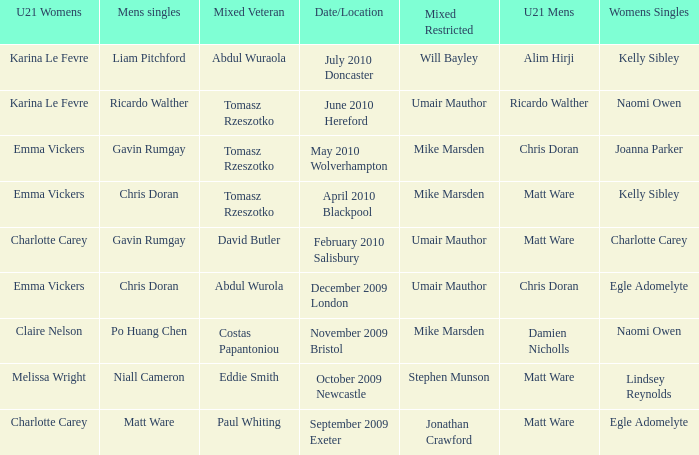When and where did Eddie Smith win the mixed veteran? 1.0. Would you be able to parse every entry in this table? {'header': ['U21 Womens', 'Mens singles', 'Mixed Veteran', 'Date/Location', 'Mixed Restricted', 'U21 Mens', 'Womens Singles'], 'rows': [['Karina Le Fevre', 'Liam Pitchford', 'Abdul Wuraola', 'July 2010 Doncaster', 'Will Bayley', 'Alim Hirji', 'Kelly Sibley'], ['Karina Le Fevre', 'Ricardo Walther', 'Tomasz Rzeszotko', 'June 2010 Hereford', 'Umair Mauthor', 'Ricardo Walther', 'Naomi Owen'], ['Emma Vickers', 'Gavin Rumgay', 'Tomasz Rzeszotko', 'May 2010 Wolverhampton', 'Mike Marsden', 'Chris Doran', 'Joanna Parker'], ['Emma Vickers', 'Chris Doran', 'Tomasz Rzeszotko', 'April 2010 Blackpool', 'Mike Marsden', 'Matt Ware', 'Kelly Sibley'], ['Charlotte Carey', 'Gavin Rumgay', 'David Butler', 'February 2010 Salisbury', 'Umair Mauthor', 'Matt Ware', 'Charlotte Carey'], ['Emma Vickers', 'Chris Doran', 'Abdul Wurola', 'December 2009 London', 'Umair Mauthor', 'Chris Doran', 'Egle Adomelyte'], ['Claire Nelson', 'Po Huang Chen', 'Costas Papantoniou', 'November 2009 Bristol', 'Mike Marsden', 'Damien Nicholls', 'Naomi Owen'], ['Melissa Wright', 'Niall Cameron', 'Eddie Smith', 'October 2009 Newcastle', 'Stephen Munson', 'Matt Ware', 'Lindsey Reynolds'], ['Charlotte Carey', 'Matt Ware', 'Paul Whiting', 'September 2009 Exeter', 'Jonathan Crawford', 'Matt Ware', 'Egle Adomelyte']]} 